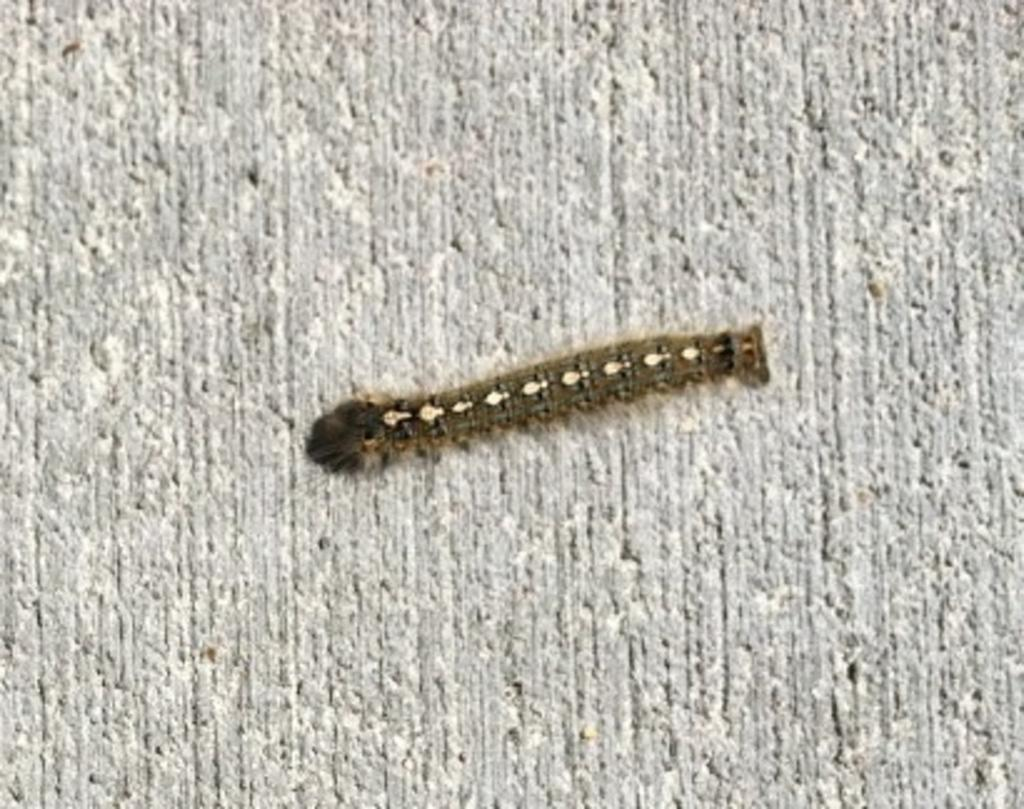What type of creature is present in the image? There is an insect in the image. Where is the insect located in the image? The insect is on a surface. What type of animal is the girl holding in the image? There is no girl or animal present in the image; it only features an insect on a surface. 